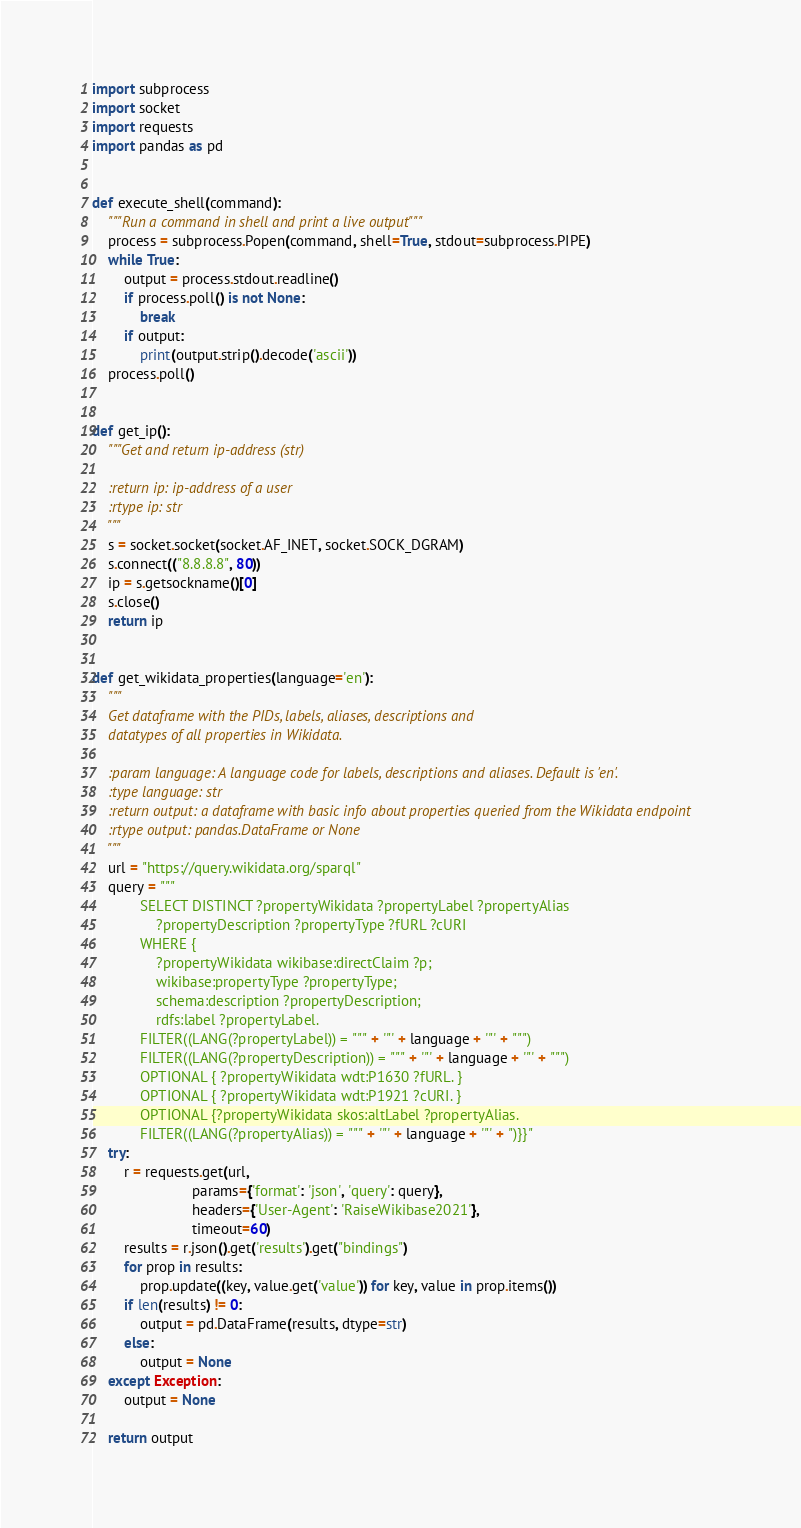<code> <loc_0><loc_0><loc_500><loc_500><_Python_>import subprocess
import socket
import requests
import pandas as pd


def execute_shell(command):
    """Run a command in shell and print a live output"""
    process = subprocess.Popen(command, shell=True, stdout=subprocess.PIPE)
    while True:
        output = process.stdout.readline()
        if process.poll() is not None:
            break
        if output:
            print(output.strip().decode('ascii'))
    process.poll()


def get_ip():
    """Get and return ip-address (str)

    :return ip: ip-address of a user
    :rtype ip: str
    """
    s = socket.socket(socket.AF_INET, socket.SOCK_DGRAM)
    s.connect(("8.8.8.8", 80))
    ip = s.getsockname()[0]
    s.close()
    return ip


def get_wikidata_properties(language='en'):
    """
    Get dataframe with the PIDs, labels, aliases, descriptions and
    datatypes of all properties in Wikidata.

    :param language: A language code for labels, descriptions and aliases. Default is 'en'.
    :type language: str
    :return output: a dataframe with basic info about properties queried from the Wikidata endpoint
    :rtype output: pandas.DataFrame or None
    """
    url = "https://query.wikidata.org/sparql"
    query = """
            SELECT DISTINCT ?propertyWikidata ?propertyLabel ?propertyAlias 
                ?propertyDescription ?propertyType ?fURL ?cURI 
            WHERE {
                ?propertyWikidata wikibase:directClaim ?p;
                wikibase:propertyType ?propertyType;
                schema:description ?propertyDescription;
                rdfs:label ?propertyLabel.
            FILTER((LANG(?propertyLabel)) = """ + '"' + language + '"' + """)
            FILTER((LANG(?propertyDescription)) = """ + '"' + language + '"' + """)
            OPTIONAL { ?propertyWikidata wdt:P1630 ?fURL. }
            OPTIONAL { ?propertyWikidata wdt:P1921 ?cURI. }
            OPTIONAL {?propertyWikidata skos:altLabel ?propertyAlias.
            FILTER((LANG(?propertyAlias)) = """ + '"' + language + '"' + ")}}"
    try:
        r = requests.get(url,
                         params={'format': 'json', 'query': query},
                         headers={'User-Agent': 'RaiseWikibase2021'},
                         timeout=60)
        results = r.json().get('results').get("bindings")
        for prop in results:
            prop.update((key, value.get('value')) for key, value in prop.items())
        if len(results) != 0:
            output = pd.DataFrame(results, dtype=str)
        else:
            output = None
    except Exception:
        output = None

    return output

</code> 